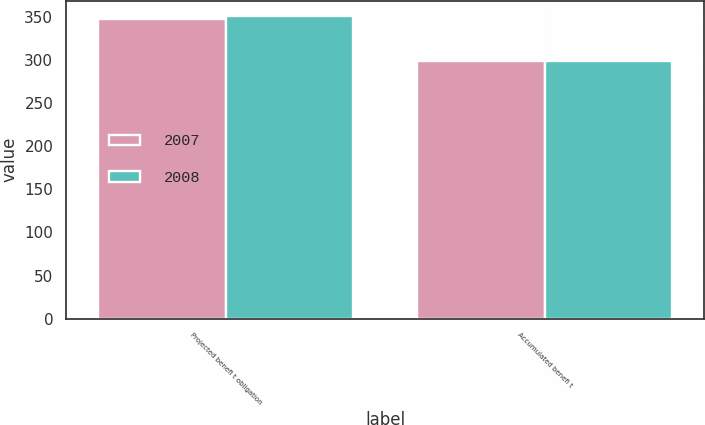Convert chart. <chart><loc_0><loc_0><loc_500><loc_500><stacked_bar_chart><ecel><fcel>Projected benefi t obligation<fcel>Accumulated benefi t<nl><fcel>2007<fcel>348.1<fcel>299.1<nl><fcel>2008<fcel>351.2<fcel>299.4<nl></chart> 